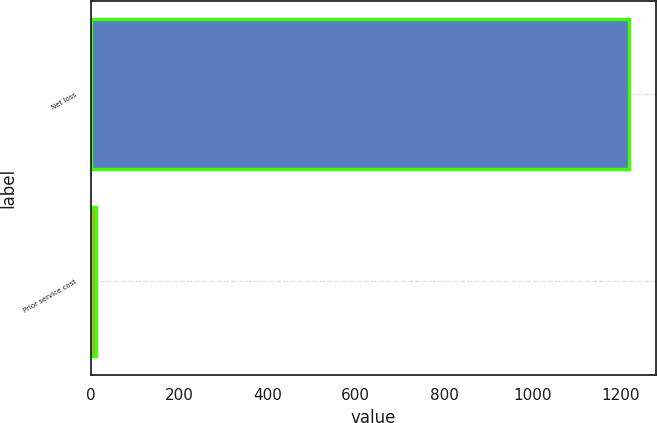Convert chart to OTSL. <chart><loc_0><loc_0><loc_500><loc_500><bar_chart><fcel>Net loss<fcel>Prior service cost<nl><fcel>1219<fcel>12<nl></chart> 